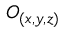Convert formula to latex. <formula><loc_0><loc_0><loc_500><loc_500>O _ { ( x , y , z ) }</formula> 